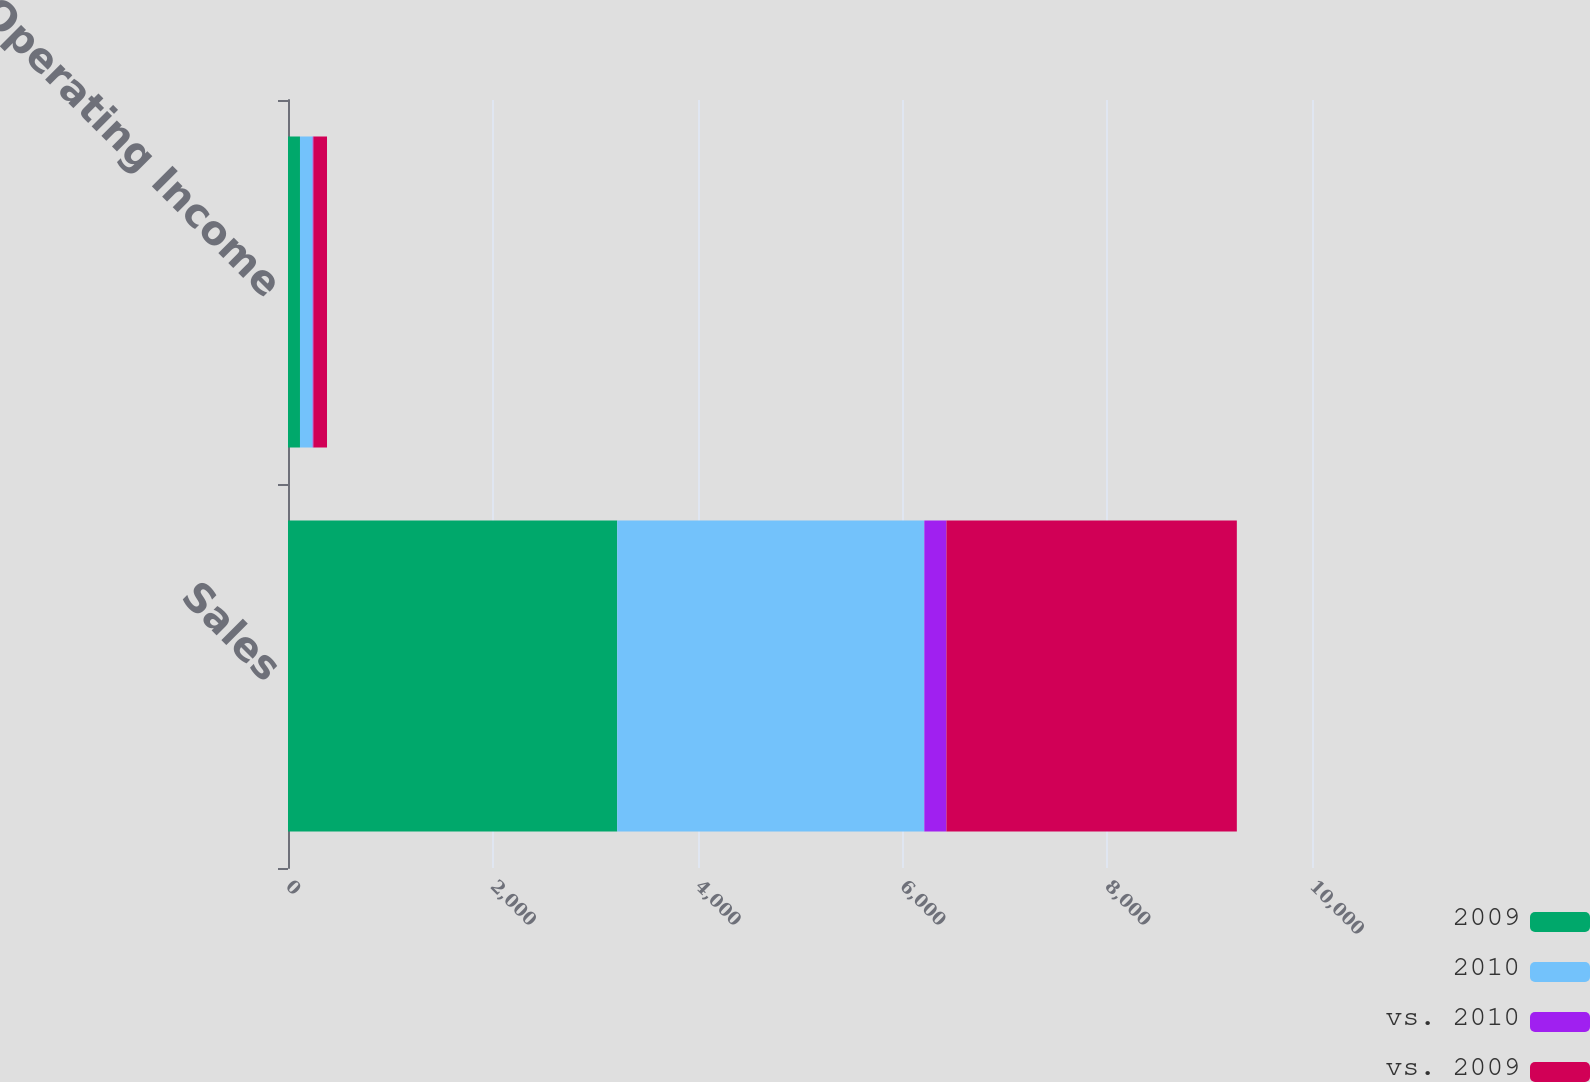<chart> <loc_0><loc_0><loc_500><loc_500><stacked_bar_chart><ecel><fcel>Sales<fcel>Operating Income<nl><fcel>2009<fcel>3215<fcel>117<nl><fcel>2010<fcel>2999<fcel>124<nl><fcel>vs. 2010<fcel>216<fcel>7<nl><fcel>vs. 2009<fcel>2836<fcel>133<nl></chart> 